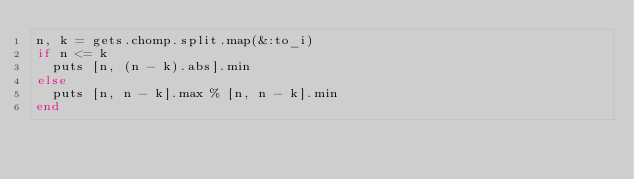<code> <loc_0><loc_0><loc_500><loc_500><_Ruby_>n, k = gets.chomp.split.map(&:to_i)
if n <= k
  puts [n, (n - k).abs].min
else
  puts [n, n - k].max % [n, n - k].min
end</code> 